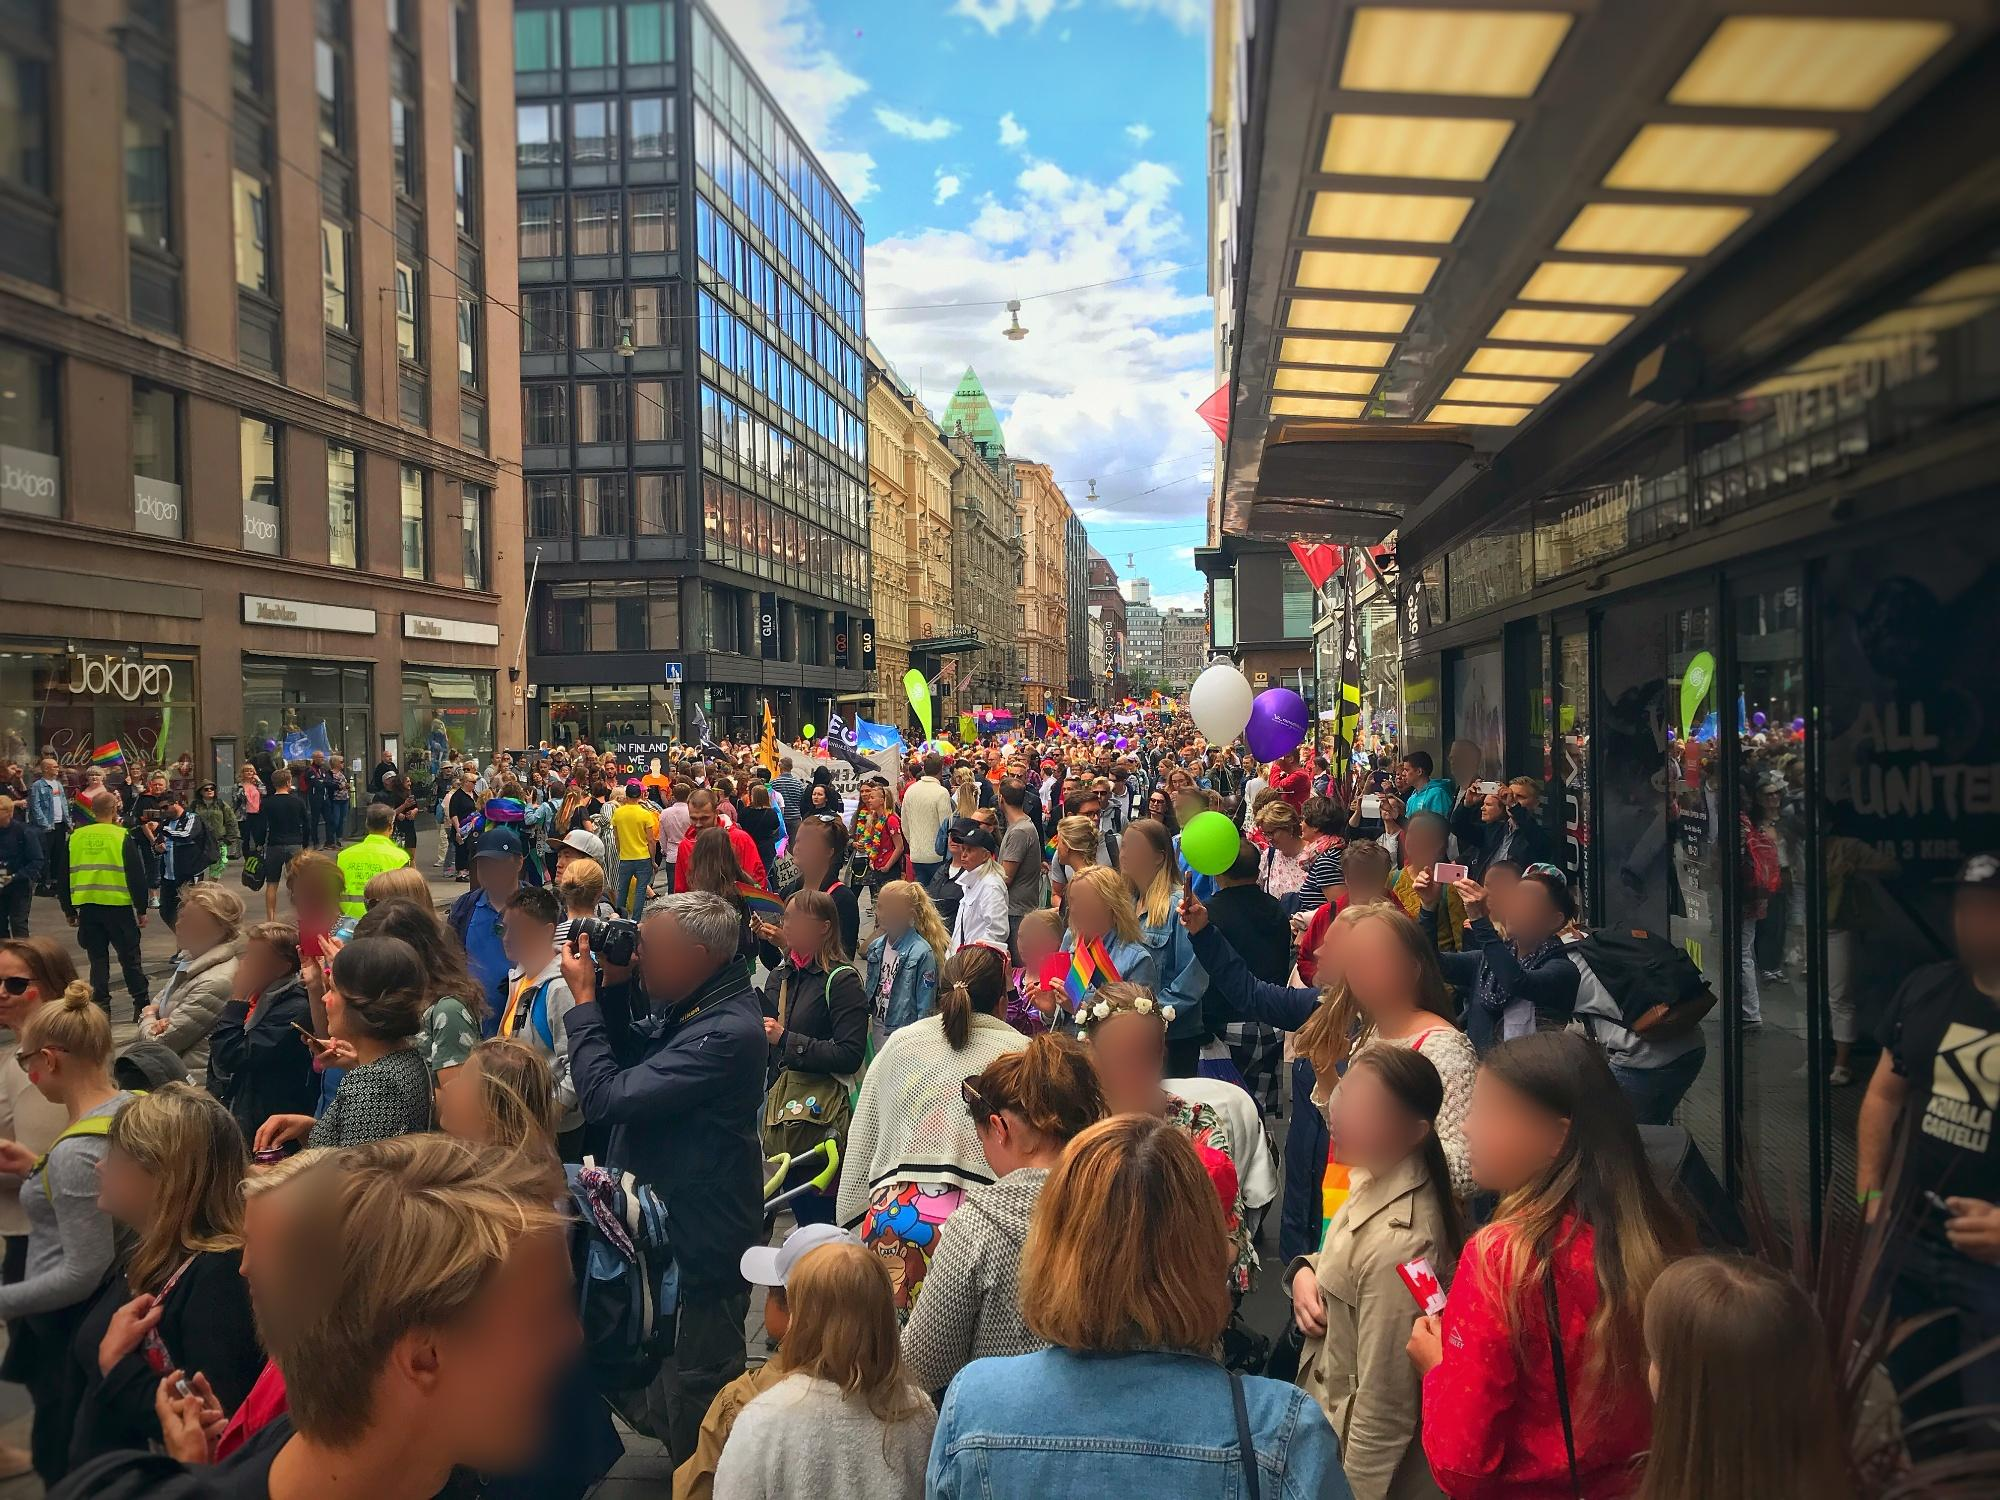If you could compare this parade to a well-known fairy tale, which one would it be and why? This parade could be compared to the fairy tale 'Alice in Wonderland'. Just like in the whimsical world Alice discovers, the parade is filled with vibrant colors, curious objects like balloons, and a diverse, animated crowd that evokes a sense of wonder and excitement. The festive atmosphere and the parade’s capacity to transport its participants into a realm of joy and imagination mirror the fantastical elements of the fairy tale, where everyday reality is transformed into an extraordinary experience. 